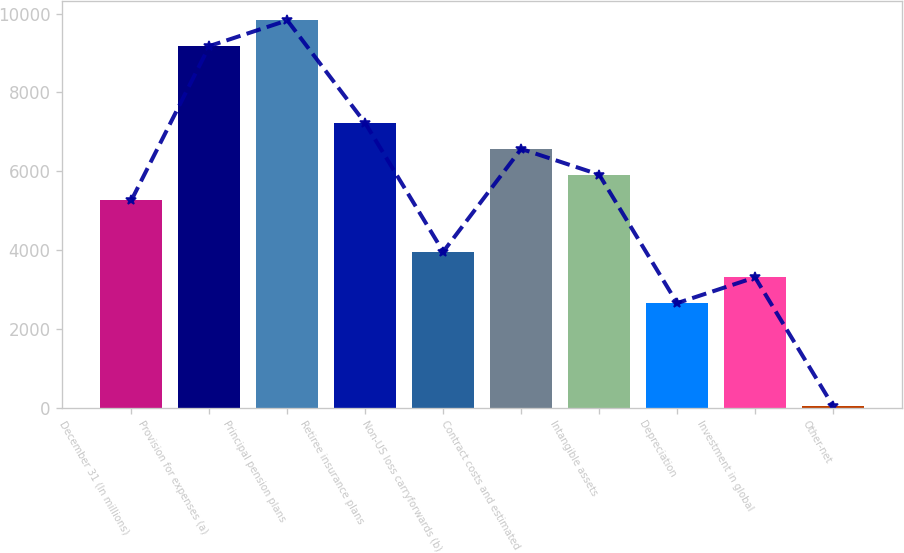Convert chart. <chart><loc_0><loc_0><loc_500><loc_500><bar_chart><fcel>December 31 (In millions)<fcel>Provision for expenses (a)<fcel>Principal pension plans<fcel>Retiree insurance plans<fcel>Non-US loss carryforwards (b)<fcel>Contract costs and estimated<fcel>Intangible assets<fcel>Depreciation<fcel>Investment in global<fcel>Other-net<nl><fcel>5262.8<fcel>9175.4<fcel>9827.5<fcel>7219.1<fcel>3958.6<fcel>6567<fcel>5914.9<fcel>2654.4<fcel>3306.5<fcel>46<nl></chart> 